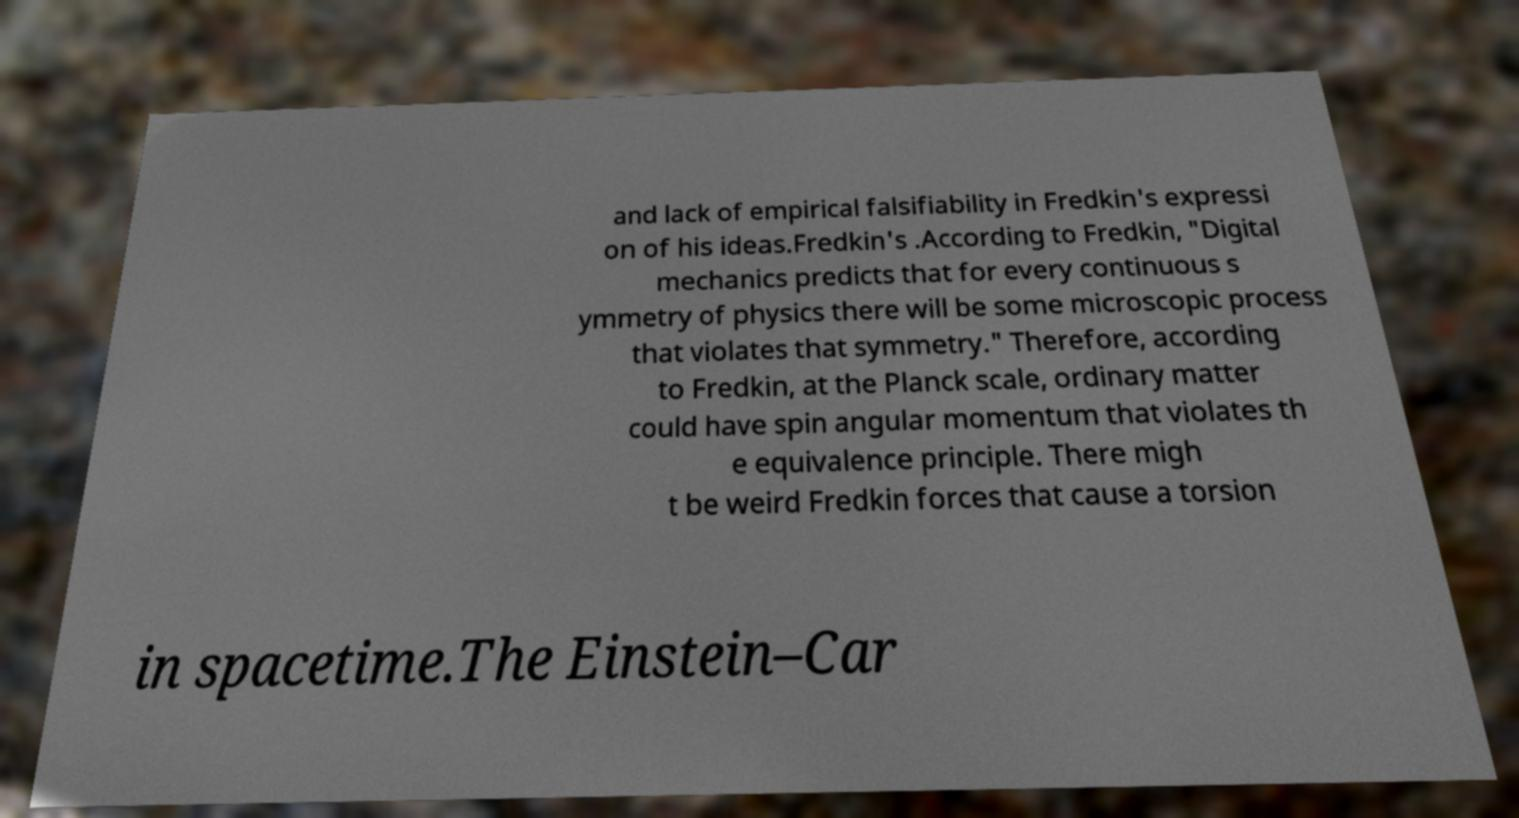Please identify and transcribe the text found in this image. and lack of empirical falsifiability in Fredkin's expressi on of his ideas.Fredkin's .According to Fredkin, "Digital mechanics predicts that for every continuous s ymmetry of physics there will be some microscopic process that violates that symmetry." Therefore, according to Fredkin, at the Planck scale, ordinary matter could have spin angular momentum that violates th e equivalence principle. There migh t be weird Fredkin forces that cause a torsion in spacetime.The Einstein–Car 